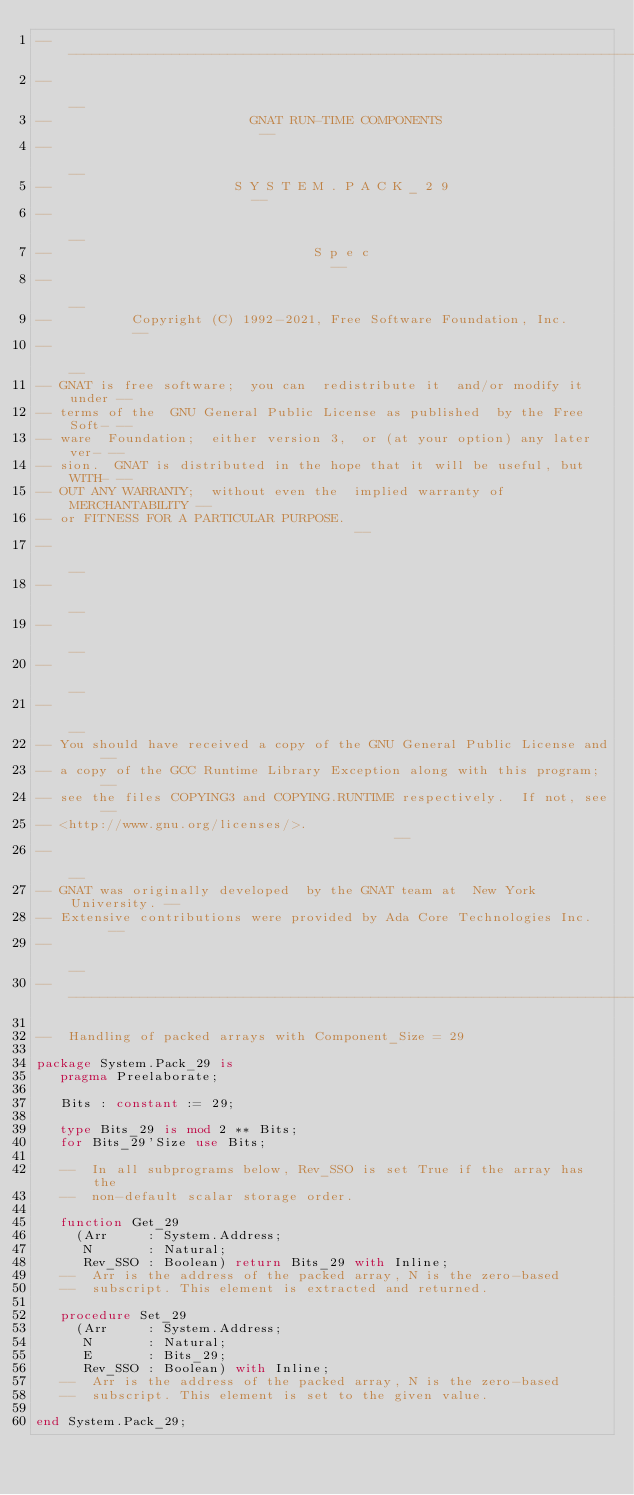<code> <loc_0><loc_0><loc_500><loc_500><_Ada_>------------------------------------------------------------------------------
--                                                                          --
--                         GNAT RUN-TIME COMPONENTS                         --
--                                                                          --
--                       S Y S T E M . P A C K _ 2 9                        --
--                                                                          --
--                                 S p e c                                  --
--                                                                          --
--          Copyright (C) 1992-2021, Free Software Foundation, Inc.         --
--                                                                          --
-- GNAT is free software;  you can  redistribute it  and/or modify it under --
-- terms of the  GNU General Public License as published  by the Free Soft- --
-- ware  Foundation;  either version 3,  or (at your option) any later ver- --
-- sion.  GNAT is distributed in the hope that it will be useful, but WITH- --
-- OUT ANY WARRANTY;  without even the  implied warranty of MERCHANTABILITY --
-- or FITNESS FOR A PARTICULAR PURPOSE.                                     --
--                                                                          --
--                                                                          --
--                                                                          --
--                                                                          --
--                                                                          --
-- You should have received a copy of the GNU General Public License and    --
-- a copy of the GCC Runtime Library Exception along with this program;     --
-- see the files COPYING3 and COPYING.RUNTIME respectively.  If not, see    --
-- <http://www.gnu.org/licenses/>.                                          --
--                                                                          --
-- GNAT was originally developed  by the GNAT team at  New York University. --
-- Extensive contributions were provided by Ada Core Technologies Inc.      --
--                                                                          --
------------------------------------------------------------------------------

--  Handling of packed arrays with Component_Size = 29

package System.Pack_29 is
   pragma Preelaborate;

   Bits : constant := 29;

   type Bits_29 is mod 2 ** Bits;
   for Bits_29'Size use Bits;

   --  In all subprograms below, Rev_SSO is set True if the array has the
   --  non-default scalar storage order.

   function Get_29
     (Arr     : System.Address;
      N       : Natural;
      Rev_SSO : Boolean) return Bits_29 with Inline;
   --  Arr is the address of the packed array, N is the zero-based
   --  subscript. This element is extracted and returned.

   procedure Set_29
     (Arr     : System.Address;
      N       : Natural;
      E       : Bits_29;
      Rev_SSO : Boolean) with Inline;
   --  Arr is the address of the packed array, N is the zero-based
   --  subscript. This element is set to the given value.

end System.Pack_29;
</code> 